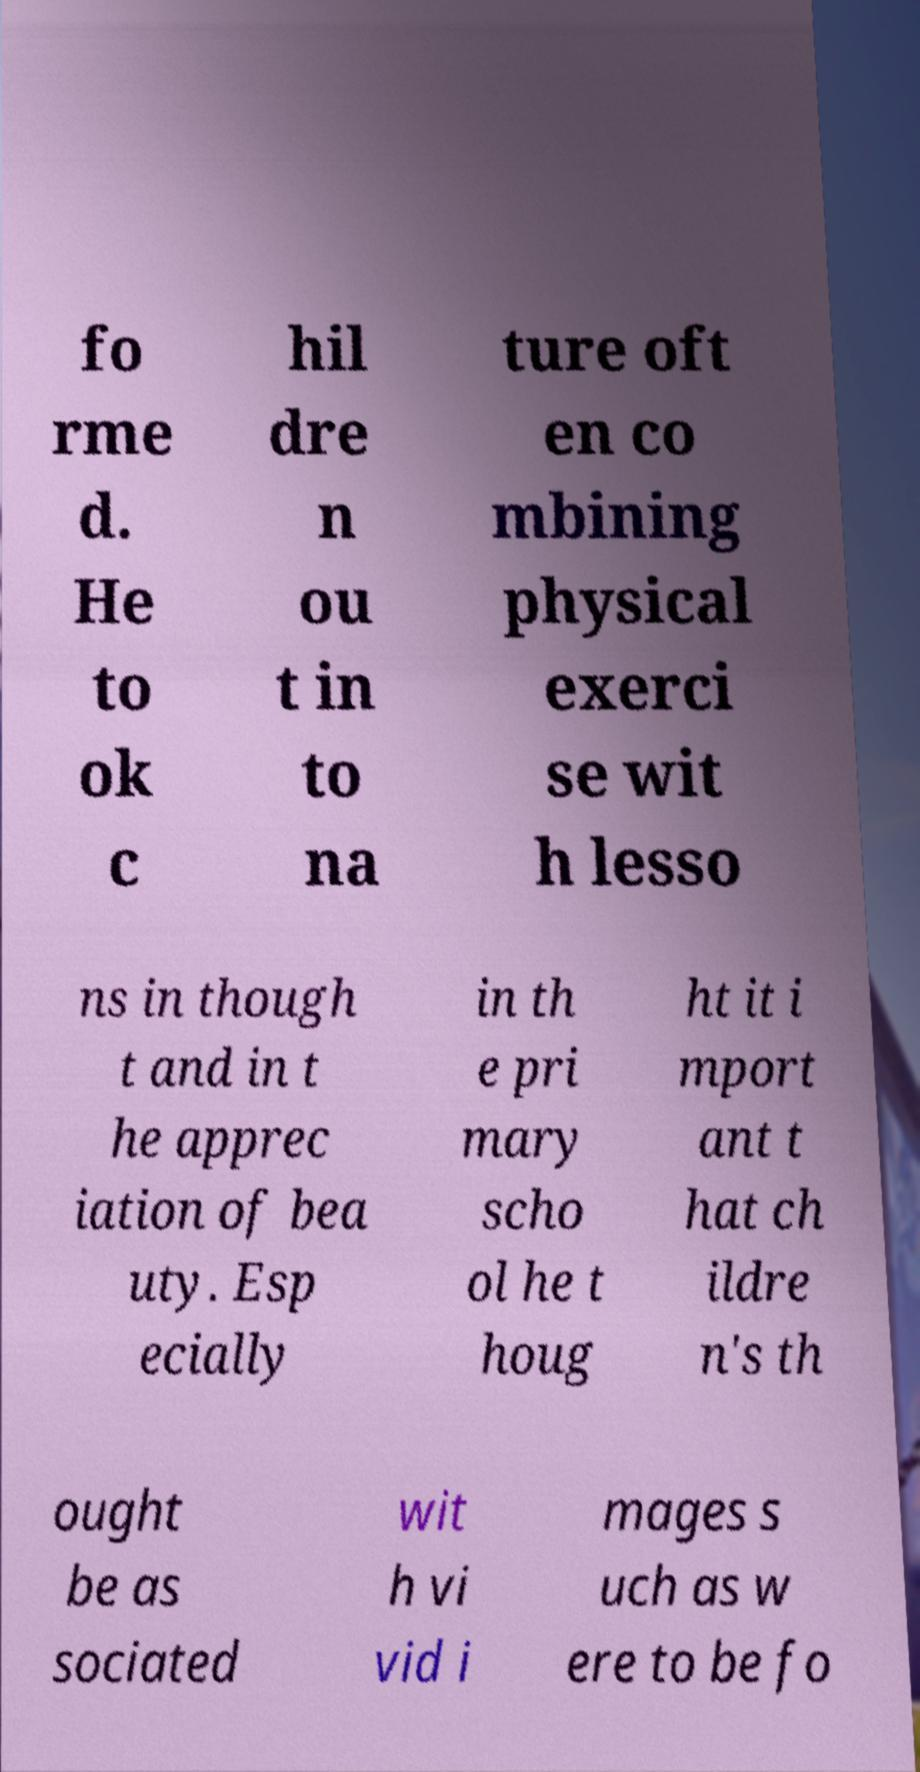There's text embedded in this image that I need extracted. Can you transcribe it verbatim? fo rme d. He to ok c hil dre n ou t in to na ture oft en co mbining physical exerci se wit h lesso ns in though t and in t he apprec iation of bea uty. Esp ecially in th e pri mary scho ol he t houg ht it i mport ant t hat ch ildre n's th ought be as sociated wit h vi vid i mages s uch as w ere to be fo 